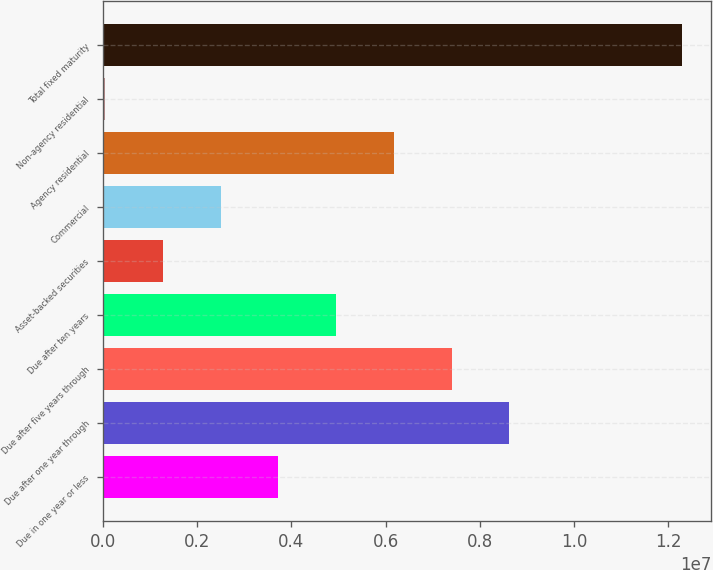<chart> <loc_0><loc_0><loc_500><loc_500><bar_chart><fcel>Due in one year or less<fcel>Due after one year through<fcel>Due after five years through<fcel>Due after ten years<fcel>Asset-backed securities<fcel>Commercial<fcel>Agency residential<fcel>Non-agency residential<fcel>Total fixed maturity<nl><fcel>3.72522e+06<fcel>8.62139e+06<fcel>7.39735e+06<fcel>4.94926e+06<fcel>1.27713e+06<fcel>2.50118e+06<fcel>6.17331e+06<fcel>53089<fcel>1.22935e+07<nl></chart> 